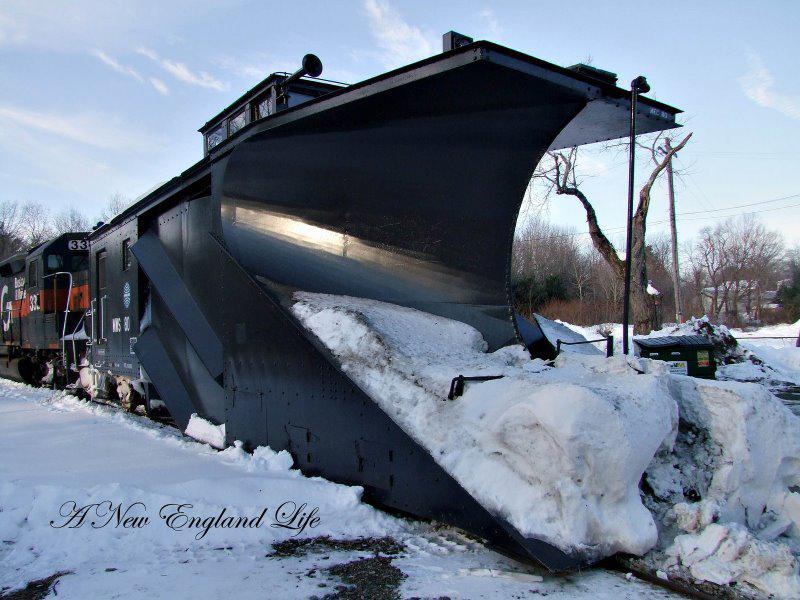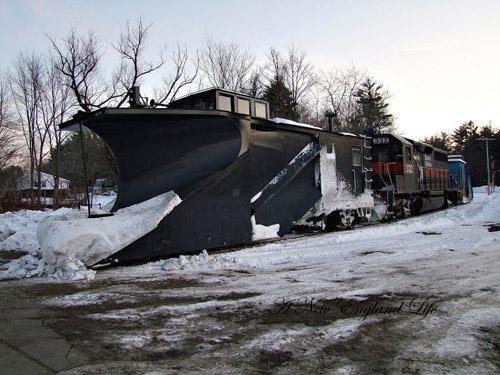The first image is the image on the left, the second image is the image on the right. Analyze the images presented: Is the assertion "The left and right image contains the same number of black trains." valid? Answer yes or no. Yes. The first image is the image on the left, the second image is the image on the right. Considering the images on both sides, is "Snow covers the area in each of the images." valid? Answer yes or no. Yes. 